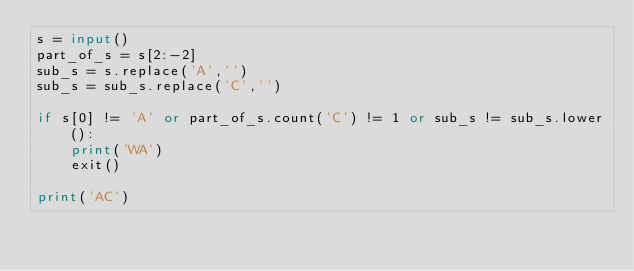Convert code to text. <code><loc_0><loc_0><loc_500><loc_500><_Python_>s = input()
part_of_s = s[2:-2]
sub_s = s.replace('A','')
sub_s = sub_s.replace('C','')

if s[0] != 'A' or part_of_s.count('C') != 1 or sub_s != sub_s.lower():
    print('WA')
    exit()

print('AC')</code> 